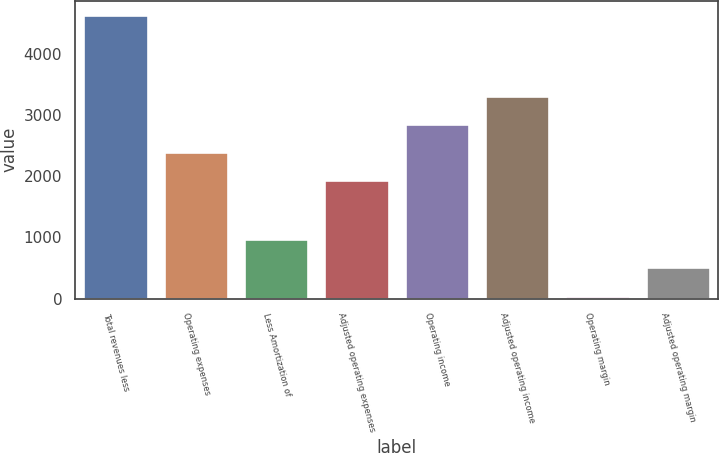Convert chart to OTSL. <chart><loc_0><loc_0><loc_500><loc_500><bar_chart><fcel>Total revenues less<fcel>Operating expenses<fcel>Less Amortization of<fcel>Adjusted operating expenses<fcel>Operating income<fcel>Adjusted operating income<fcel>Operating margin<fcel>Adjusted operating margin<nl><fcel>4629<fcel>2395.8<fcel>966.6<fcel>1938<fcel>2853.6<fcel>3311.4<fcel>51<fcel>508.8<nl></chart> 